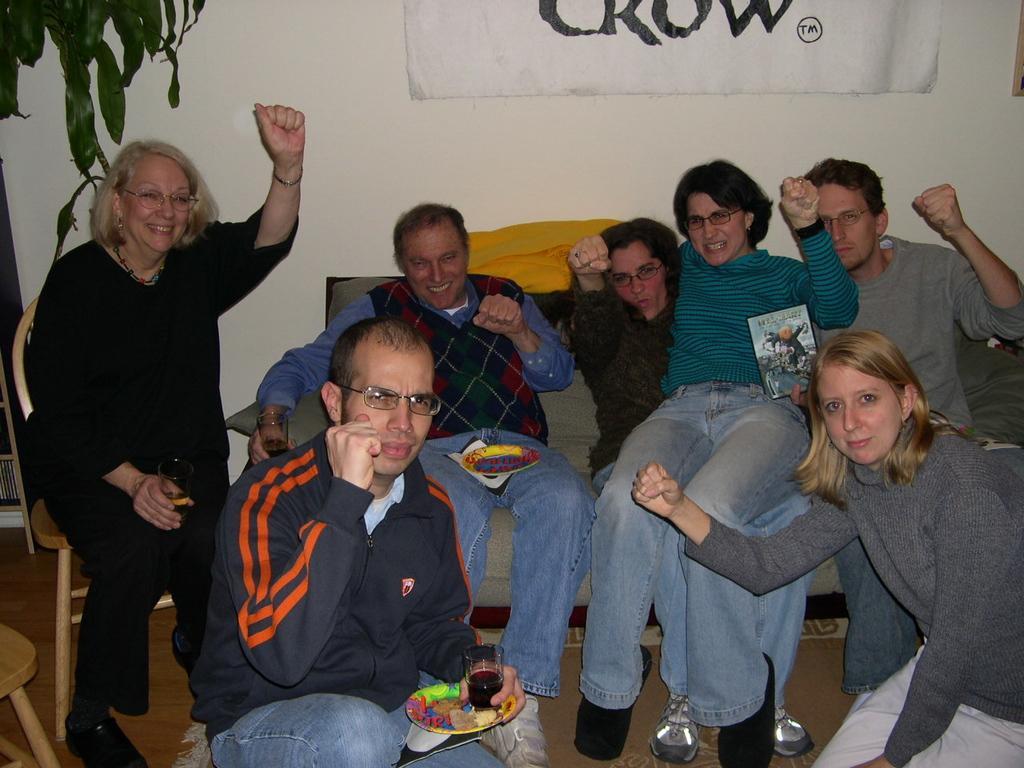Could you give a brief overview of what you see in this image? In this picture we can see some people are sitting, a man in the front is holding a plate and a glass of drink, in the background there is a wall, we can see a chart pasted to the wall, there is a plant at the left top of the picture. 